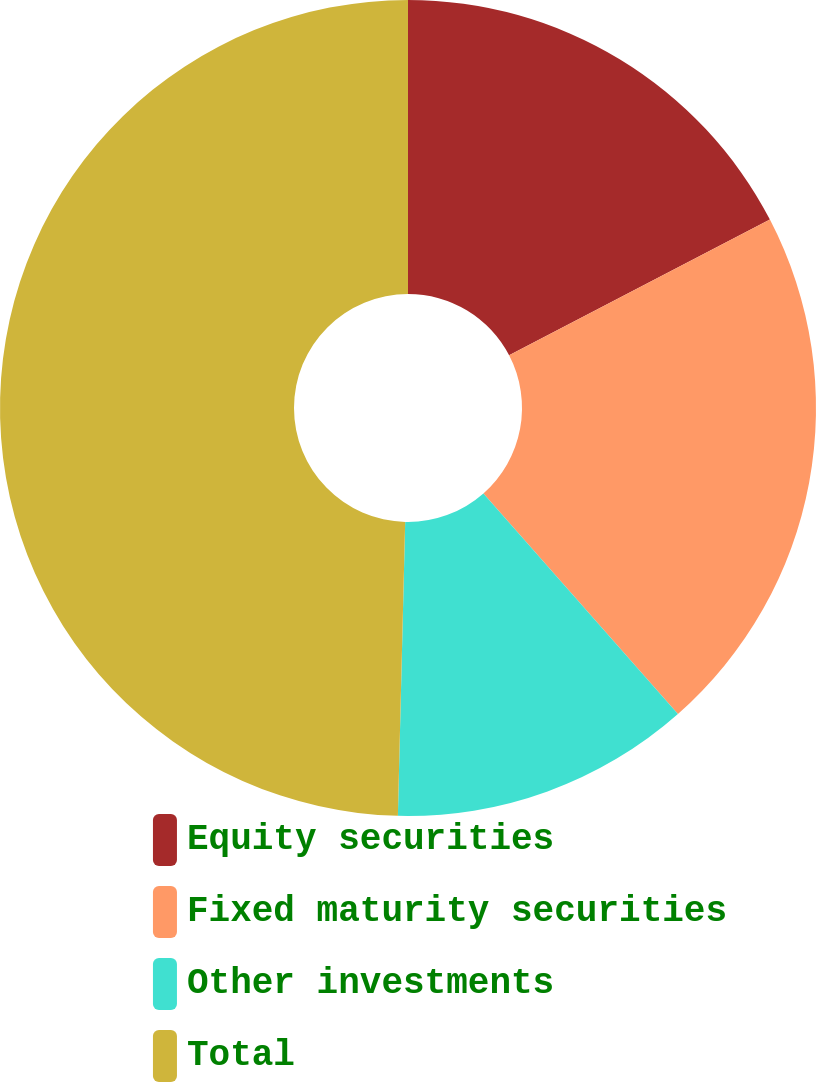Convert chart to OTSL. <chart><loc_0><loc_0><loc_500><loc_500><pie_chart><fcel>Equity securities<fcel>Fixed maturity securities<fcel>Other investments<fcel>Total<nl><fcel>17.36%<fcel>21.13%<fcel>11.9%<fcel>49.6%<nl></chart> 